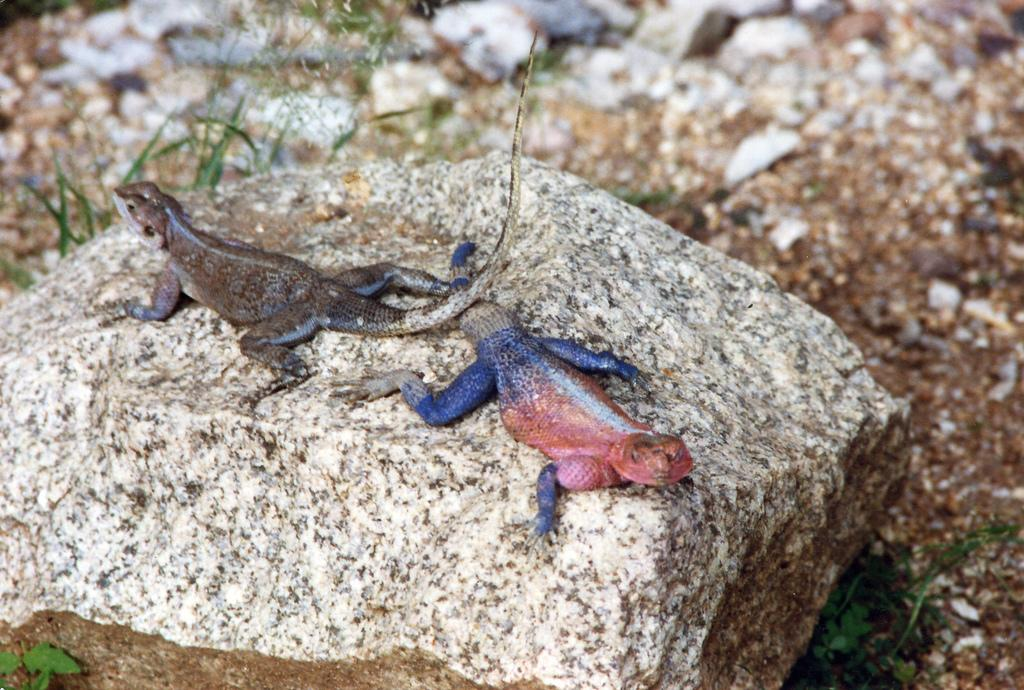What is the main object in the image? There is a stone in the image. What is on top of the stone? There are two chameleons on the stone. What can be seen in the background of the image? There is grass visible in the background of the image. How is the grass depicted in the image? The grass appears blurred. What type of bell can be heard ringing in the image? There is no bell present in the image, and therefore no sound can be heard. How does the eggnog contribute to the image? There is no eggnog mentioned or depicted in the image. 